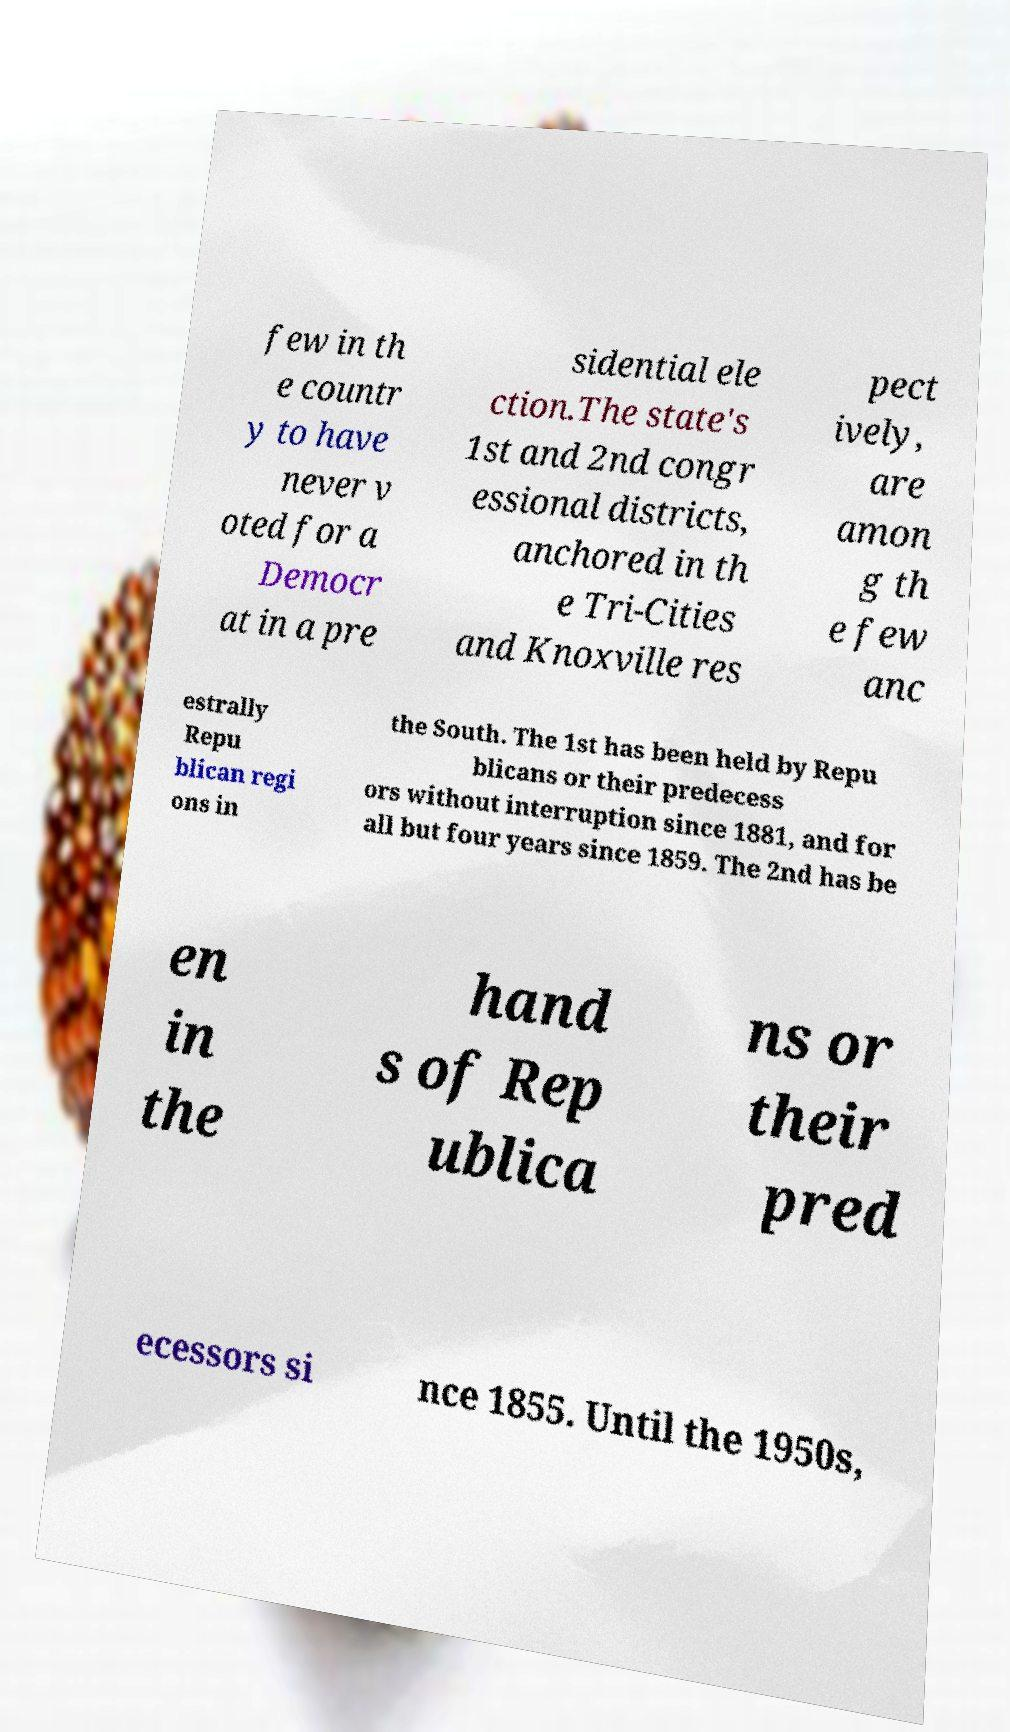Could you assist in decoding the text presented in this image and type it out clearly? few in th e countr y to have never v oted for a Democr at in a pre sidential ele ction.The state's 1st and 2nd congr essional districts, anchored in th e Tri-Cities and Knoxville res pect ively, are amon g th e few anc estrally Repu blican regi ons in the South. The 1st has been held by Repu blicans or their predecess ors without interruption since 1881, and for all but four years since 1859. The 2nd has be en in the hand s of Rep ublica ns or their pred ecessors si nce 1855. Until the 1950s, 